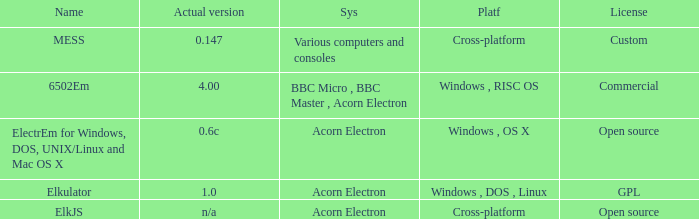What is the system called that is named ELKJS? Acorn Electron. 